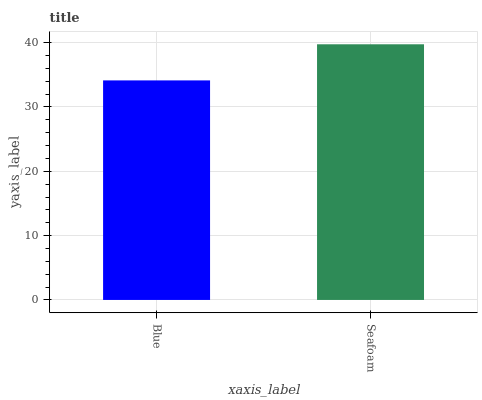Is Blue the minimum?
Answer yes or no. Yes. Is Seafoam the maximum?
Answer yes or no. Yes. Is Seafoam the minimum?
Answer yes or no. No. Is Seafoam greater than Blue?
Answer yes or no. Yes. Is Blue less than Seafoam?
Answer yes or no. Yes. Is Blue greater than Seafoam?
Answer yes or no. No. Is Seafoam less than Blue?
Answer yes or no. No. Is Seafoam the high median?
Answer yes or no. Yes. Is Blue the low median?
Answer yes or no. Yes. Is Blue the high median?
Answer yes or no. No. Is Seafoam the low median?
Answer yes or no. No. 